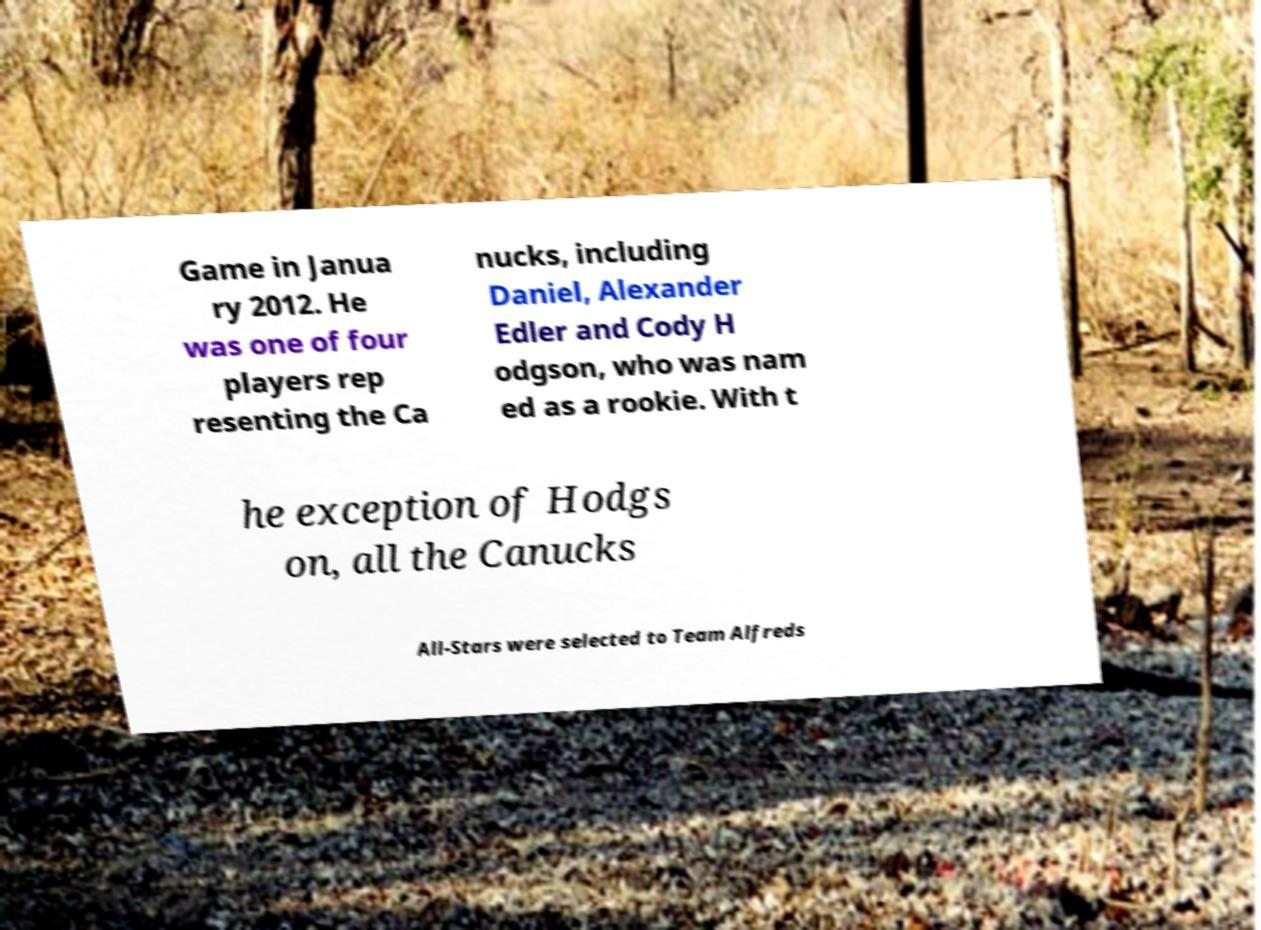Could you extract and type out the text from this image? Game in Janua ry 2012. He was one of four players rep resenting the Ca nucks, including Daniel, Alexander Edler and Cody H odgson, who was nam ed as a rookie. With t he exception of Hodgs on, all the Canucks All-Stars were selected to Team Alfreds 